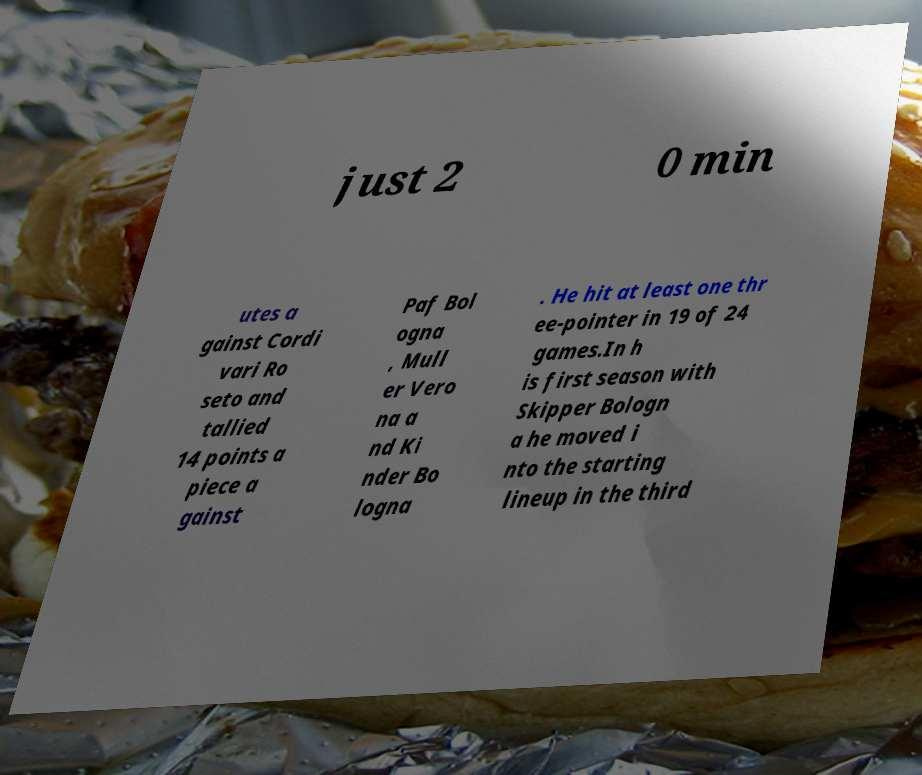Could you extract and type out the text from this image? just 2 0 min utes a gainst Cordi vari Ro seto and tallied 14 points a piece a gainst Paf Bol ogna , Mull er Vero na a nd Ki nder Bo logna . He hit at least one thr ee-pointer in 19 of 24 games.In h is first season with Skipper Bologn a he moved i nto the starting lineup in the third 